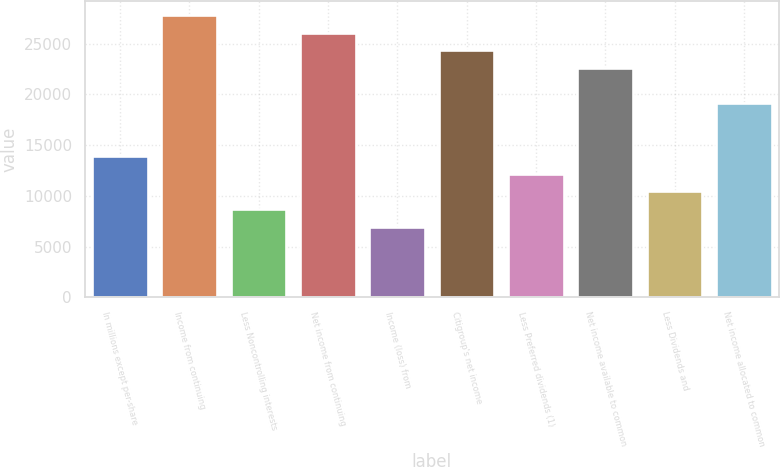<chart> <loc_0><loc_0><loc_500><loc_500><bar_chart><fcel>In millions except per-share<fcel>Income from continuing<fcel>Less Noncontrolling interests<fcel>Net income from continuing<fcel>Income (loss) from<fcel>Citigroup's net income<fcel>Less Preferred dividends (1)<fcel>Net income available to common<fcel>Less Dividends and<fcel>Net income allocated to common<nl><fcel>13908.8<fcel>27817.5<fcel>8693.05<fcel>26079<fcel>6954.46<fcel>24340.4<fcel>12170.2<fcel>22601.8<fcel>10431.6<fcel>19124.6<nl></chart> 